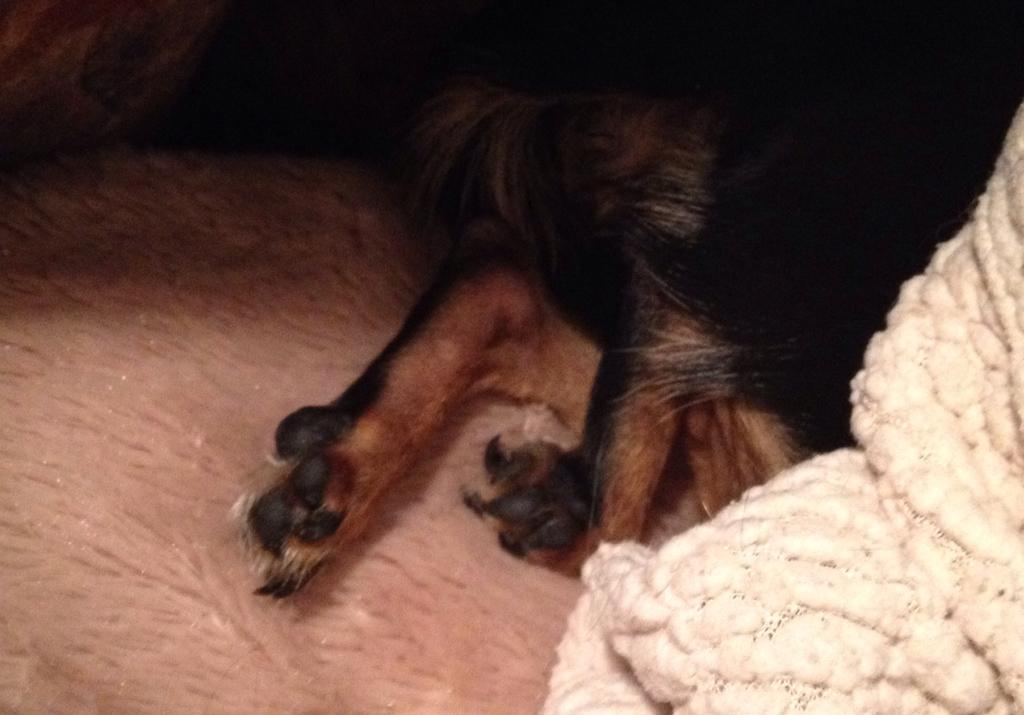What type of animal is in the image? There is an animal in the image, but its specific type cannot be determined from the provided facts. How can you describe the coloring of the animal? The animal has black and brown coloring. What is the animal resting on in the image? The animal is on a cream-colored cloth. Are there any other cloths visible in the image? Yes, there is a white-colored cloth in the image. How many deer are present in the image? There is no deer present in the image; it only features an animal with black and brown coloring on a cream-colored cloth. What type of dolls can be seen interacting with the fan in the image? There are no dolls or fans present in the image. 